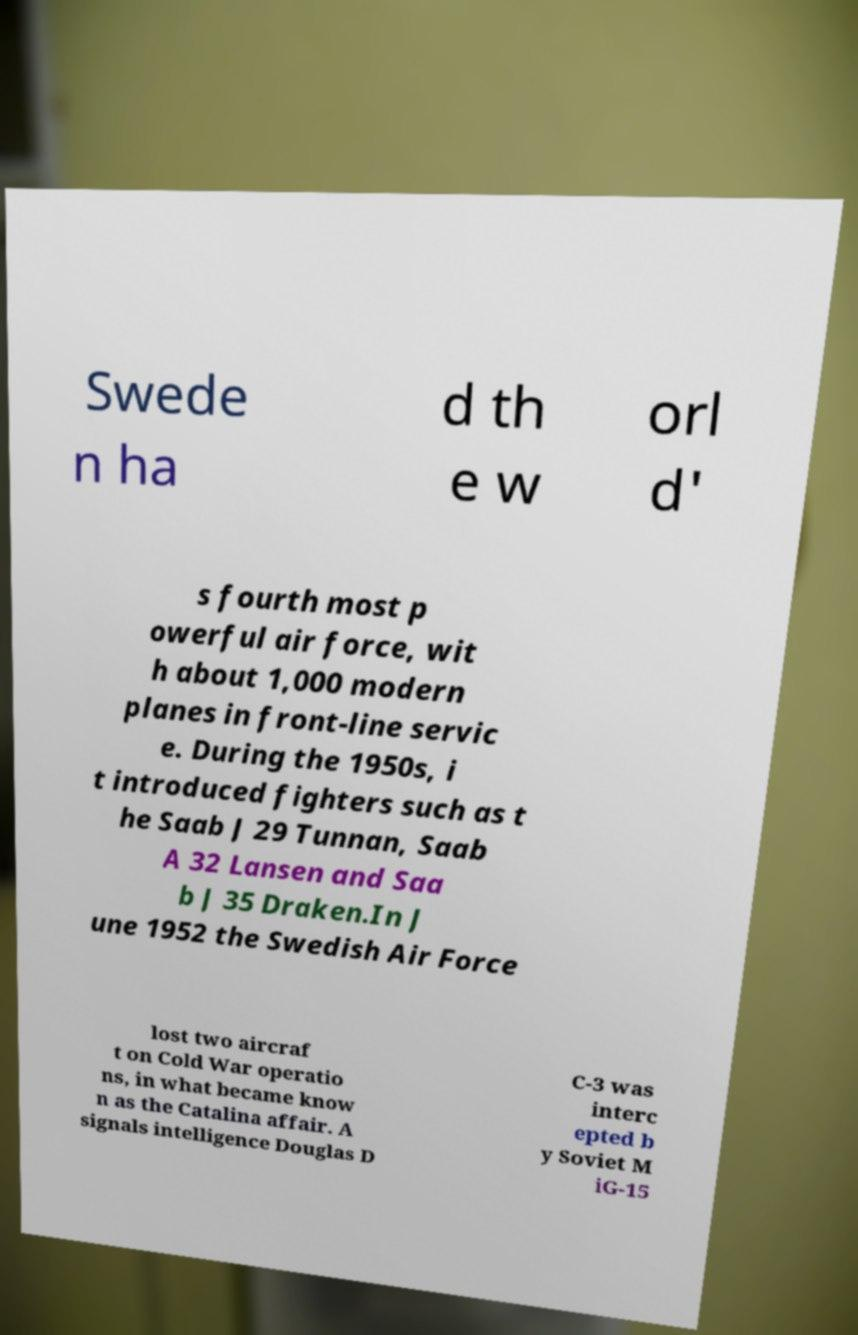Can you read and provide the text displayed in the image?This photo seems to have some interesting text. Can you extract and type it out for me? Swede n ha d th e w orl d' s fourth most p owerful air force, wit h about 1,000 modern planes in front-line servic e. During the 1950s, i t introduced fighters such as t he Saab J 29 Tunnan, Saab A 32 Lansen and Saa b J 35 Draken.In J une 1952 the Swedish Air Force lost two aircraf t on Cold War operatio ns, in what became know n as the Catalina affair. A signals intelligence Douglas D C-3 was interc epted b y Soviet M iG-15 